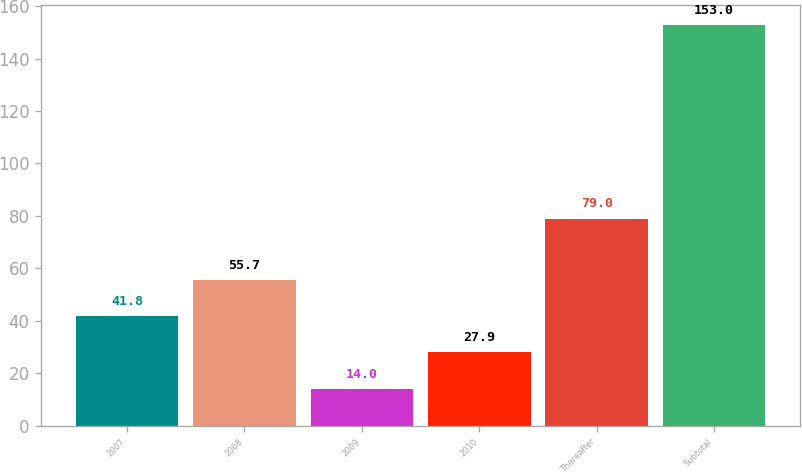Convert chart. <chart><loc_0><loc_0><loc_500><loc_500><bar_chart><fcel>2007<fcel>2008<fcel>2009<fcel>2010<fcel>Thereafter<fcel>Subtotal<nl><fcel>41.8<fcel>55.7<fcel>14<fcel>27.9<fcel>79<fcel>153<nl></chart> 